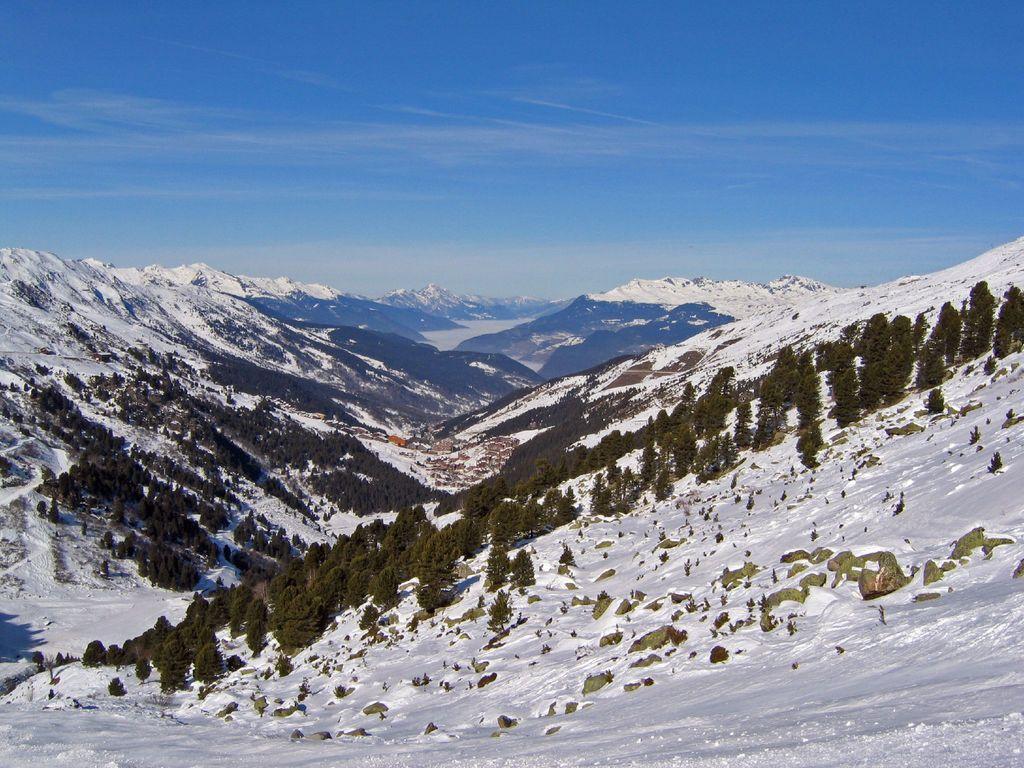Describe this image in one or two sentences. This image is taken outdoors. At the top of the image there is a sky with clouds. At the bottom of the image there are a few hills and there are many trees and plants covered with snow. 